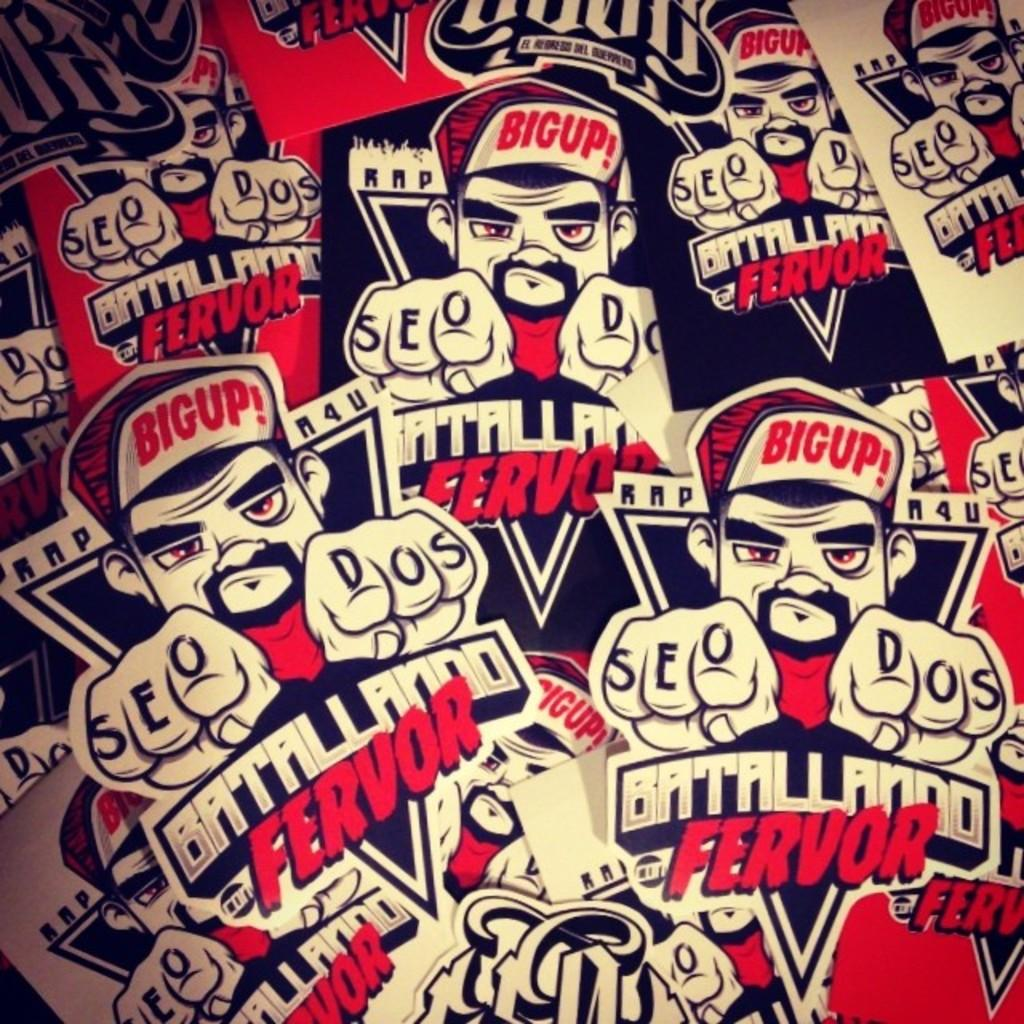What can be seen on the posters in the image? The posters contain images and text. Can you describe the images on the posters? Unfortunately, the specific images on the posters cannot be determined from the provided facts. What type of information is conveyed through the text on the posters? The content of the text on the posters cannot be determined from the provided facts. How many wings can be seen on the posters in the image? There are no wings present on the posters in the image. What type of beds are depicted on the posters? There are no beds depicted on the posters in the image. 